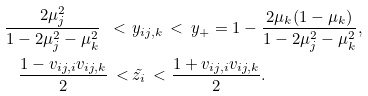<formula> <loc_0><loc_0><loc_500><loc_500>\frac { 2 \mu _ { j } ^ { 2 } } { 1 - 2 \mu _ { j } ^ { 2 } - \mu _ { k } ^ { 2 } } \ < \ & y _ { i j , k } \ < \ y _ { + } = 1 - \frac { 2 \mu _ { k } ( 1 - \mu _ { k } ) } { 1 - 2 \mu _ { j } ^ { 2 } - \mu _ { k } ^ { 2 } } , \\ \frac { 1 - v _ { i j , i } v _ { i j , k } } { 2 } \ < \ & \tilde { z _ { i } } \ < \frac { 1 + v _ { i j , i } v _ { i j , k } } { 2 } .</formula> 